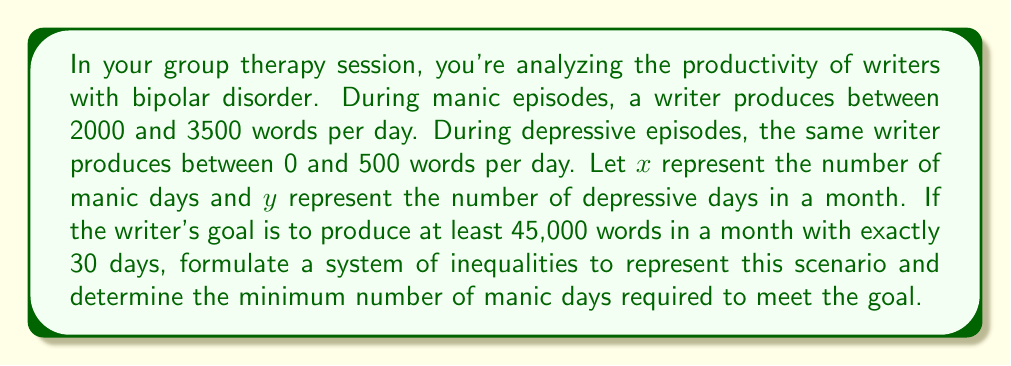Can you answer this question? 1. Let's set up the system of inequalities:

   $$\begin{cases}
   2000x + 0y \leq \text{manic production} \leq 3500x + 500y \\
   x + y = 30 \\
   2000x + 0y \geq 45000
   \end{cases}$$

2. Simplify the system:

   $$\begin{cases}
   2000x \leq \text{manic production} \leq 3500x + 500y \\
   x + y = 30 \\
   2000x \geq 45000
   \end{cases}$$

3. Solve for the minimum number of manic days:

   From $2000x \geq 45000$:
   $$x \geq \frac{45000}{2000} = 22.5$$

4. Since $x$ must be a whole number, we round up:

   $x \geq 23$

5. Verify that this satisfies the other constraints:

   $y = 30 - x = 30 - 23 = 7$
   
   Minimum total production: $2000(23) + 0(7) = 46000 \geq 45000$
   Maximum total production: $3500(23) + 500(7) = 84000$

6. Therefore, the minimum number of manic days required is 23.
Answer: 23 manic days 